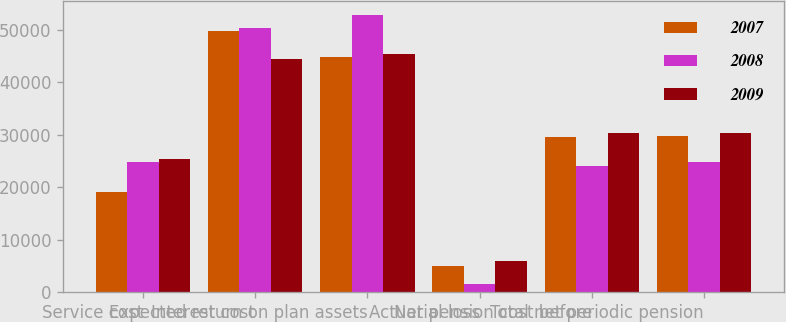Convert chart. <chart><loc_0><loc_0><loc_500><loc_500><stacked_bar_chart><ecel><fcel>Service cost<fcel>Interest cost<fcel>Expected return on plan assets<fcel>Actuarial loss<fcel>Net pension cost before<fcel>Total net periodic pension<nl><fcel>2007<fcel>19212<fcel>49781<fcel>44837<fcel>5116<fcel>29565<fcel>29768<nl><fcel>2008<fcel>24763<fcel>50421<fcel>52884<fcel>1687<fcel>24120<fcel>24874<nl><fcel>2009<fcel>25366<fcel>44486<fcel>45481<fcel>5974<fcel>30345<fcel>30345<nl></chart> 